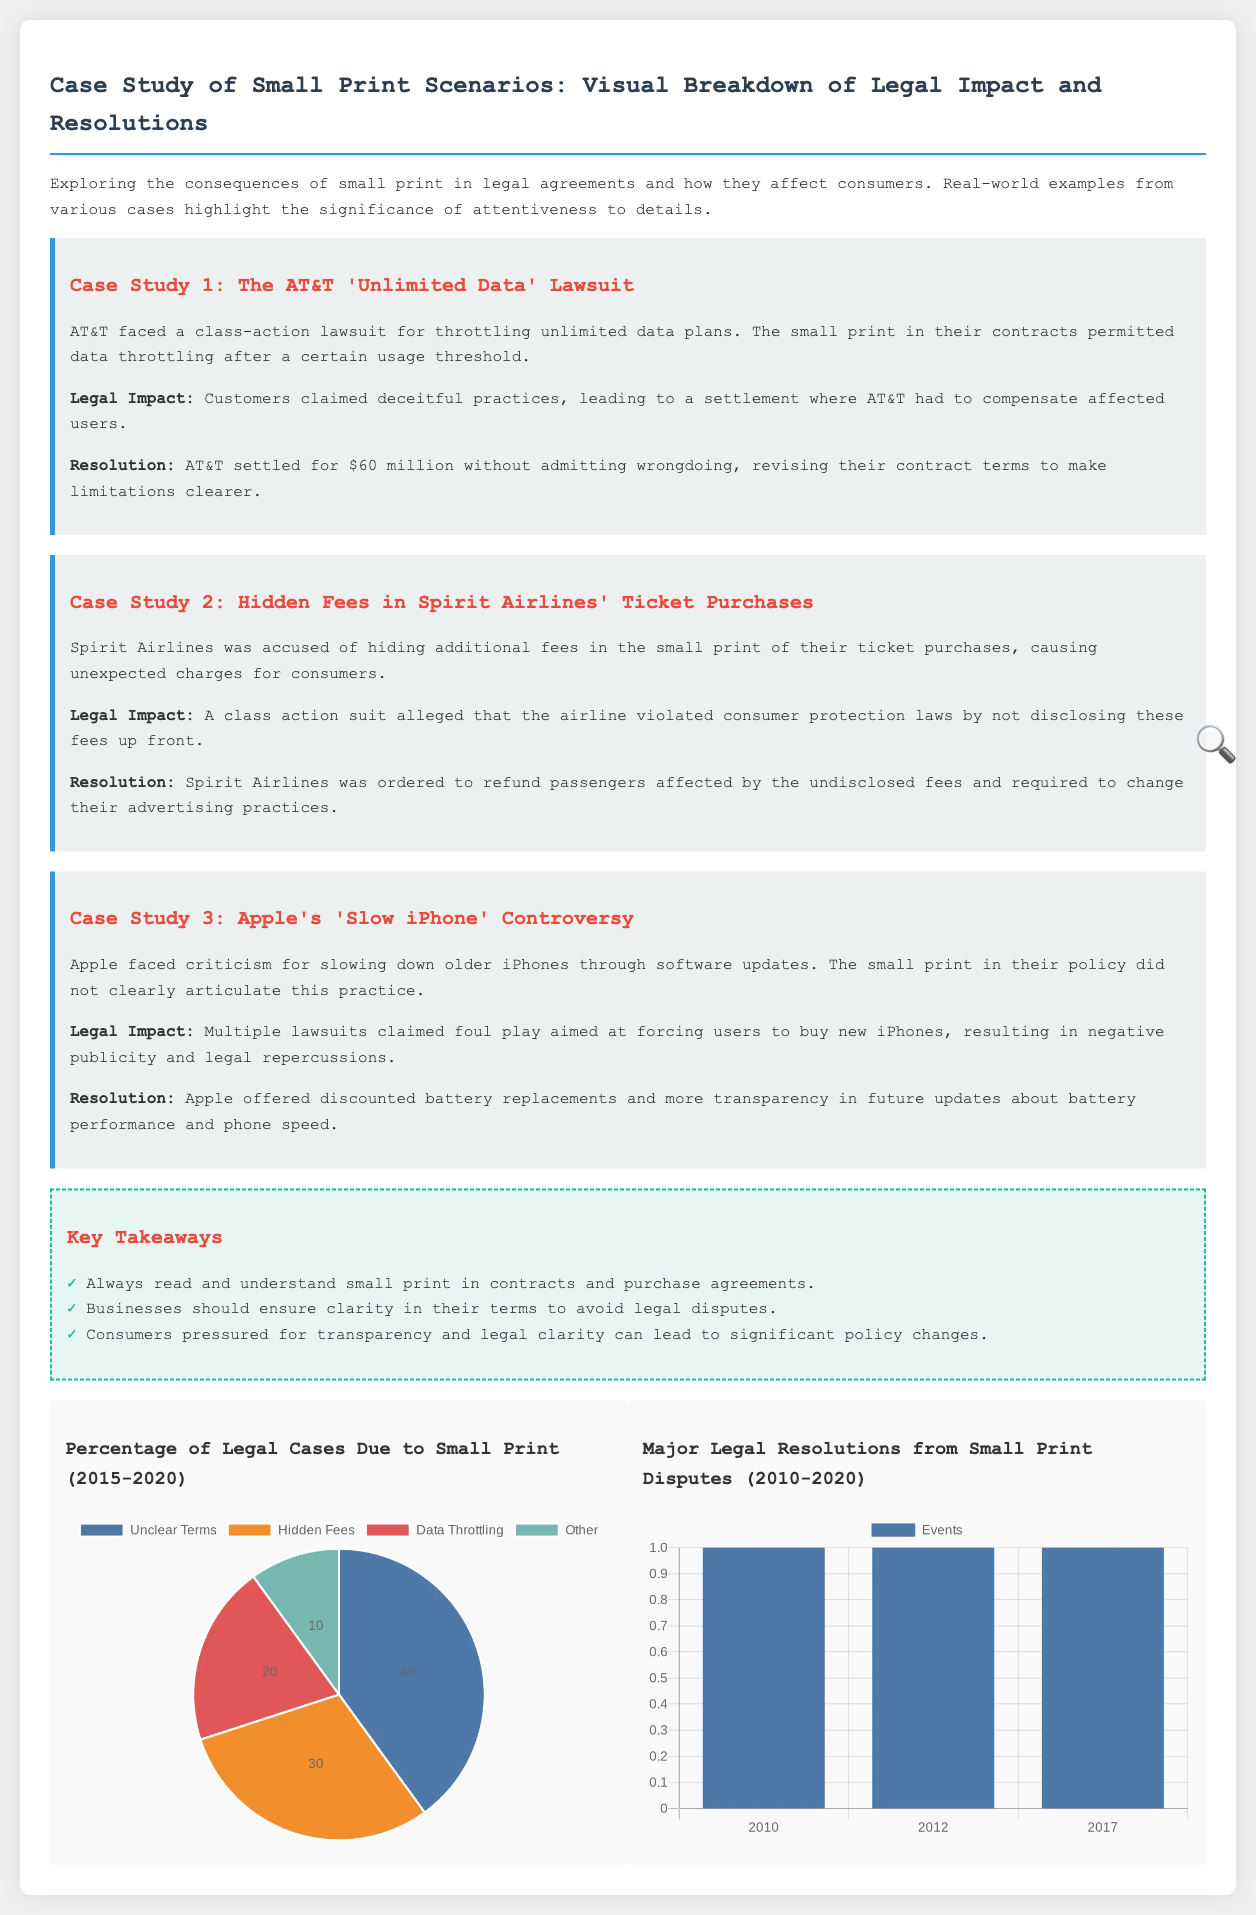What was the compensation amount in the AT&T lawsuit? The compensation amount was part of a settlement that AT&T faced in a lawsuit related to throttling unlimited data plans, which resulted in a $60 million settlement.
Answer: $60 million What did Spirit Airlines hide in the small print? Spirit Airlines was accused of hiding additional fees in the small print of their ticket purchases, leading to unexpected charges for consumers.
Answer: Additional fees What issue did Apple face regarding older iPhones? Apple faced criticism for slowing down older iPhones, an issue linked to their policy that was not clearly articulated in the small print.
Answer: Slowing down What percentage of legal cases due to small print were related to unclear terms? The percentage of legal cases due to small print related to unclear terms as shown in a pie chart is specified as 40%.
Answer: 40% What is one key takeaway regarding consumers from the document? One key takeaway is that consumers pressured for transparency and legal clarity can lead to significant policy changes, highlighting the power of consumer advocacy.
Answer: Transparency How many major legal resolution events occurred in 2010? The number of major legal resolution events that occurred in 2010, as indicated by the bar chart, is mentioned as 1.
Answer: 1 